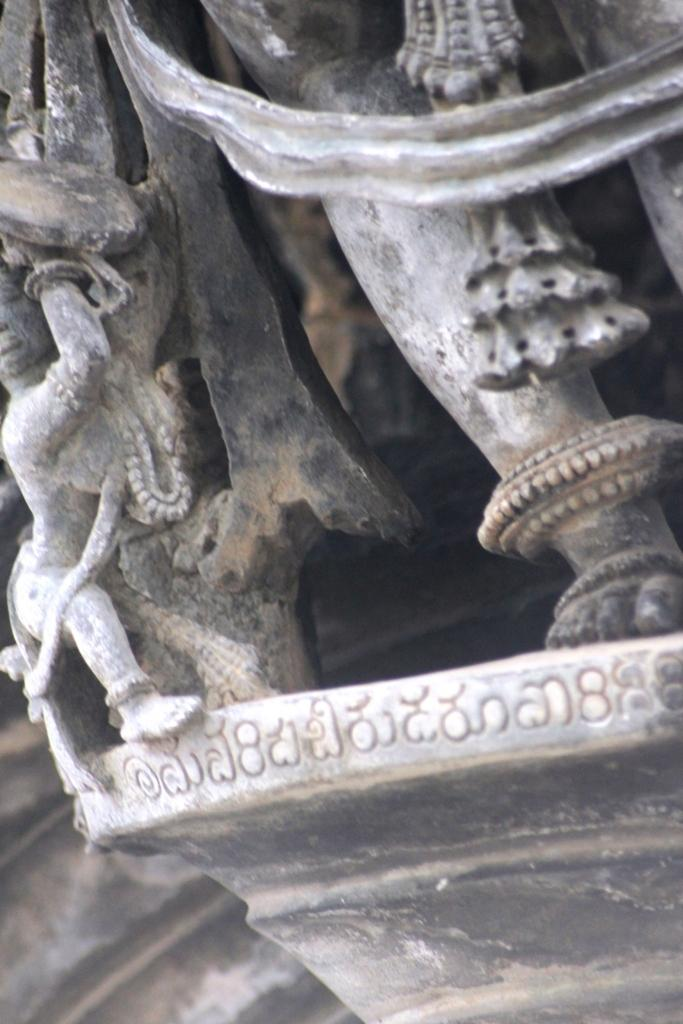What type of artwork is present in the image? There are sculptures in the image. Is there any text associated with the sculptures? Yes, there is text in the image. What type of cake is being served at the event in the image? There is no cake or event present in the image; it features sculptures and text. What is the condition of the person's neck in the image? There are no people or necks visible in the image. 